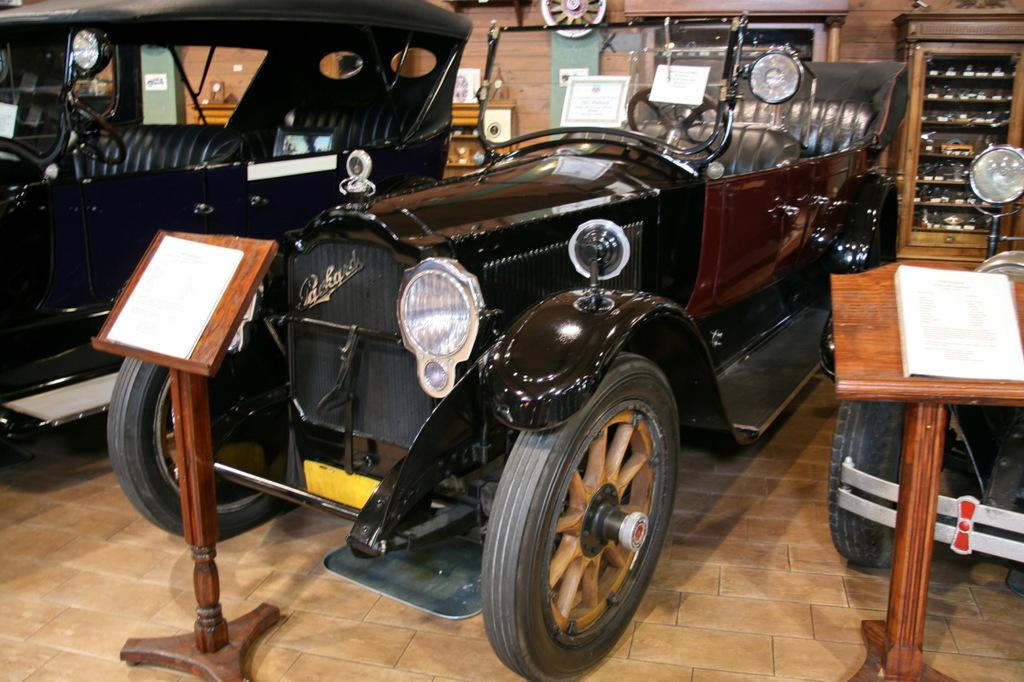What type of vehicles are featured in the image? The image displays old vintage cars. What additional information is provided about the cars? There is a stand in front of at least one car, providing information about it. What can be seen in the background of the image? There is a wall and cupboards in the background of the image. What is the name of the flower with a long stem that is growing next to the cars in the image? There are no flowers or stems visible in the image; it features old vintage cars and a stand with information about them. 